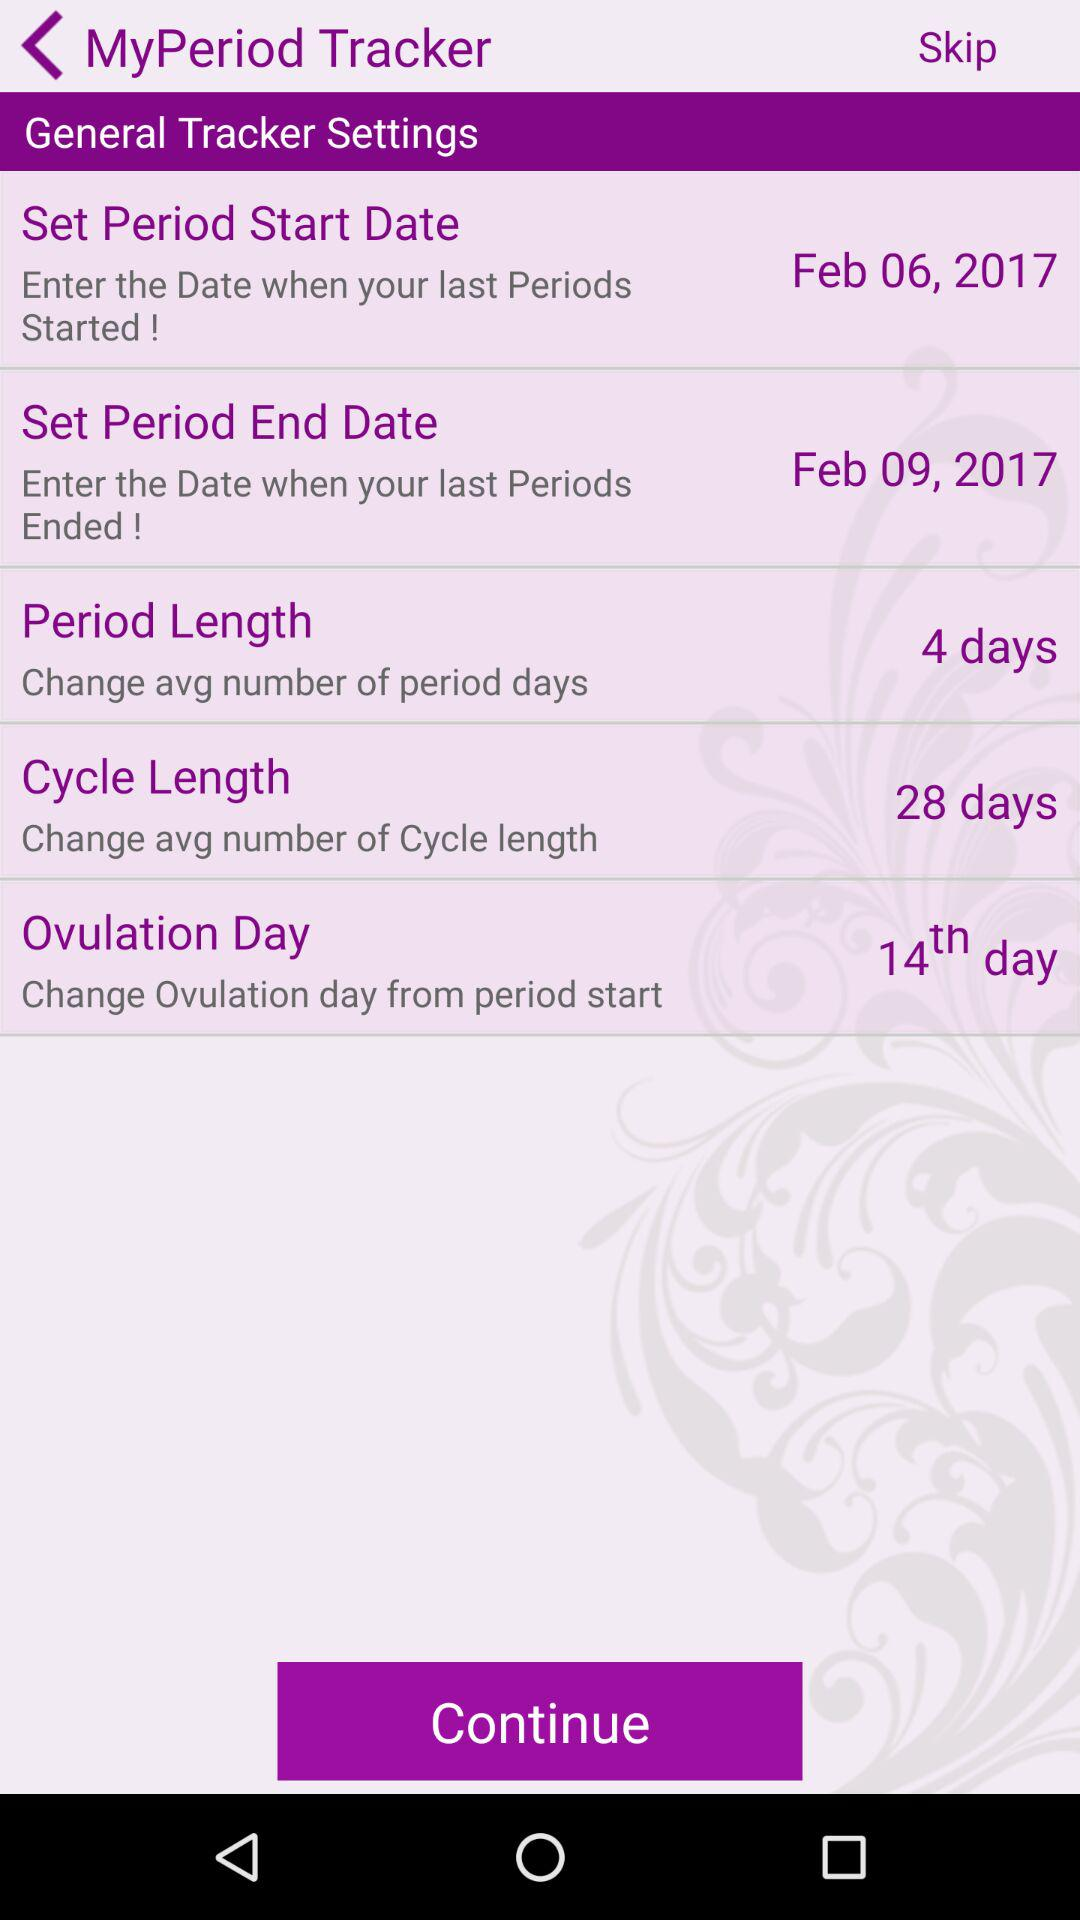What is the period's end date? The period's end date is February 9, 2017. 